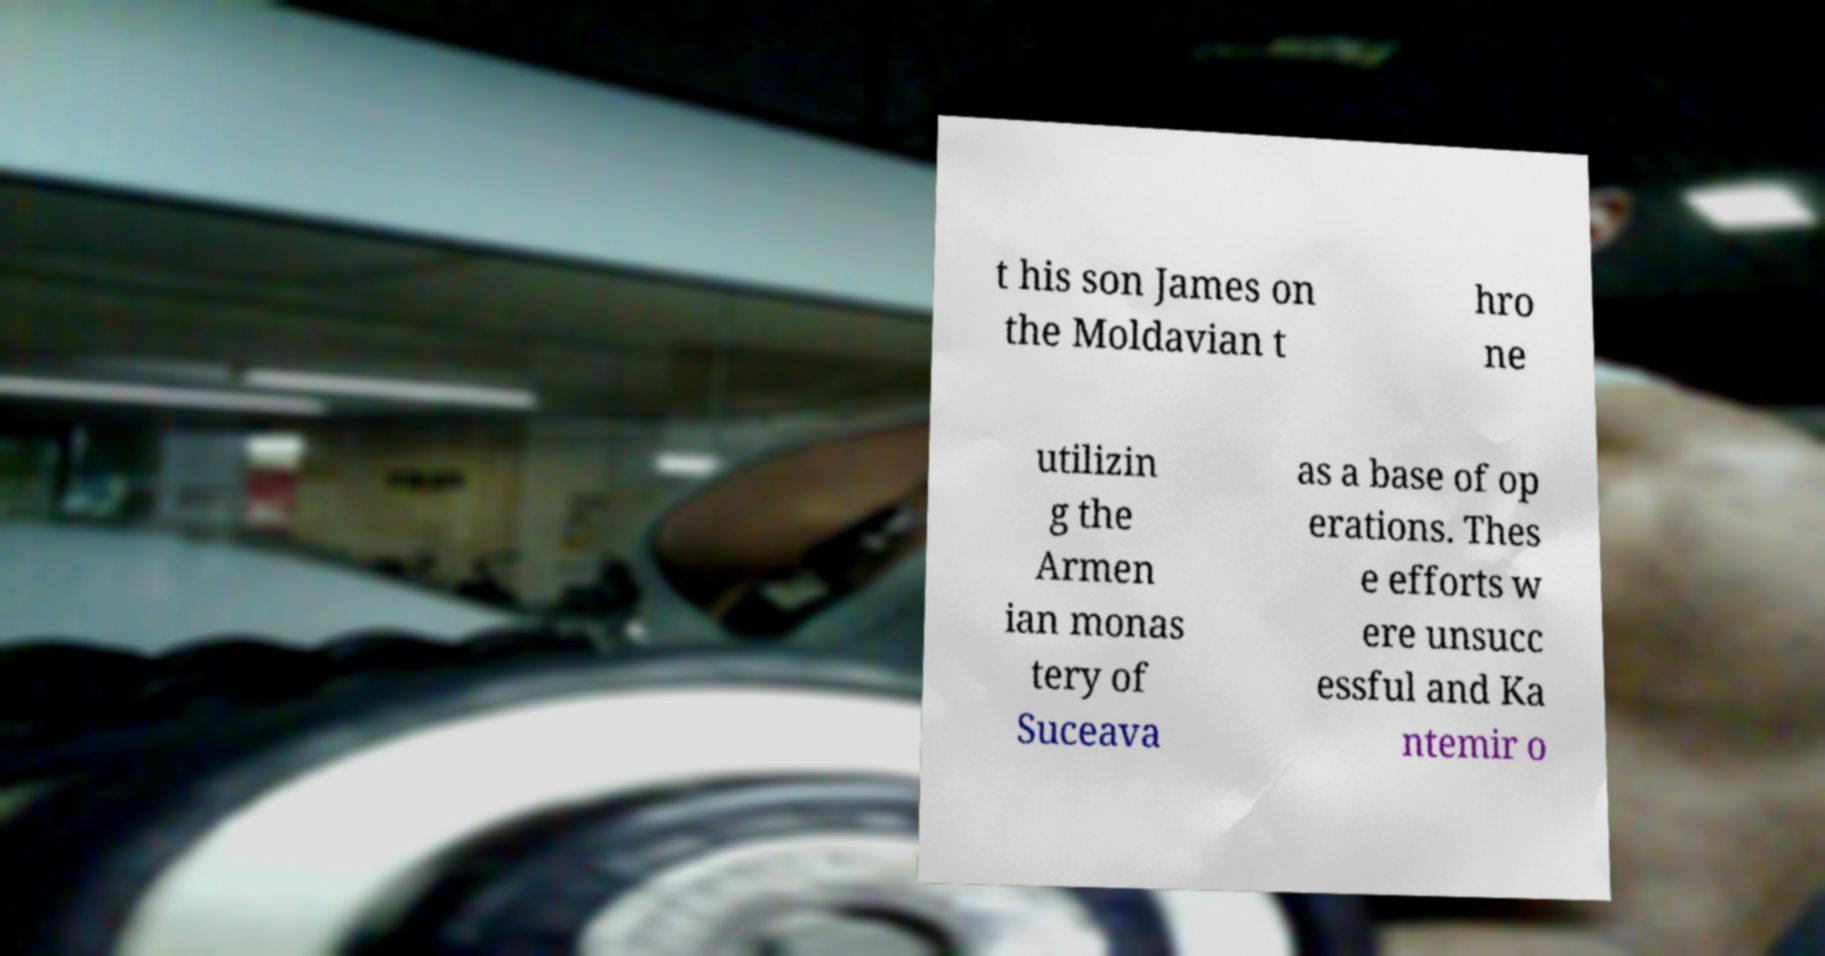For documentation purposes, I need the text within this image transcribed. Could you provide that? t his son James on the Moldavian t hro ne utilizin g the Armen ian monas tery of Suceava as a base of op erations. Thes e efforts w ere unsucc essful and Ka ntemir o 